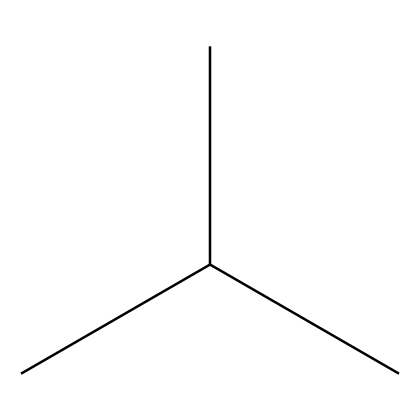What is the molecular formula of polypropylene represented by this SMILES? The SMILES CC(C)C corresponds to a structure with three carbon atoms (C). In polypropylene, each carbon is bonded to hydrogen atoms; therefore, for every carbon, there would be hydrogen atoms to complete their tetrahedral configuration. The empirical formula is C3H6 for the base unit reflected in this notation.
Answer: C3H6 How many carbon atoms are in polypropylene according to this SMILES? In the SMILES CC(C)C, every 'C' represents a carbon atom. The given structure contains four 'C's. Therefore, the total number of carbon atoms is counted directly from the SMILES.
Answer: 4 How many hydrogen atoms are present in polypropylene based on the given SMILES? In polypropylene, for every carbon atom, you can generally assess the number of hydrogen atoms based on saturation rules. Given that there are 4 carbon atoms (from CC(C)C), you can apply the general formula for alkanes to find that for n carbon atoms, there are 2n + 2 hydrogen atoms; thus, 2(4) + 2 equals 10 hydrogen atoms.
Answer: 10 What type of polymer does the SMILES represent? The structure CC(C)C is indicative of polypropylene, which is a type of polyolefin. It is a polymer made from the addition of propylene monomers. The repeating unit in noticeable in its structure confirms its classification as an addition polymer.
Answer: polyolefin Is polypropylene a thermoplastic or a thermoset? Polypropylene, which corresponds to the given SMILES CC(C)C, is recognized as a thermoplastic. Thermoplastics can be melted and reshaped multiple times without significant chemical change, which characterizes polypropylene's properties.
Answer: thermoplastic What common products are made using polypropylene? Items such as children's toys, storage containers, and automotive parts are commonly produced using polypropylene. The versatility and safety of polypropylene as a polymer make it suitable for many products, especially those that children may use.
Answer: children's toys 